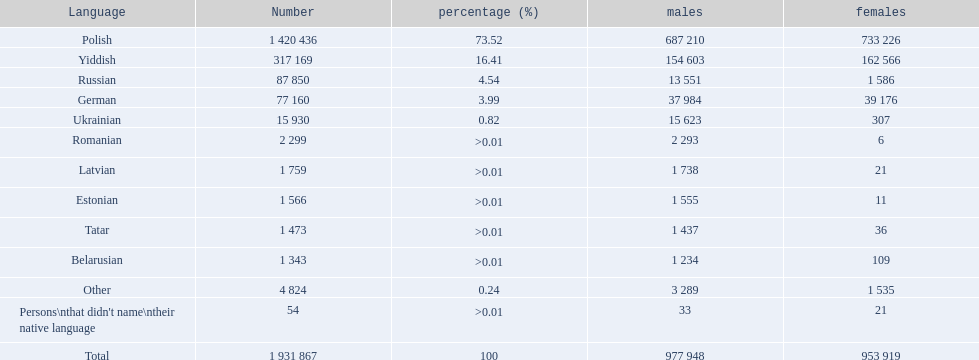What are all the languages? Polish, Yiddish, Russian, German, Ukrainian, Romanian, Latvian, Estonian, Tatar, Belarusian, Other. Which only have percentages >0.01? Romanian, Latvian, Estonian, Tatar, Belarusian. Of these, which has the greatest number of speakers? Romanian. 